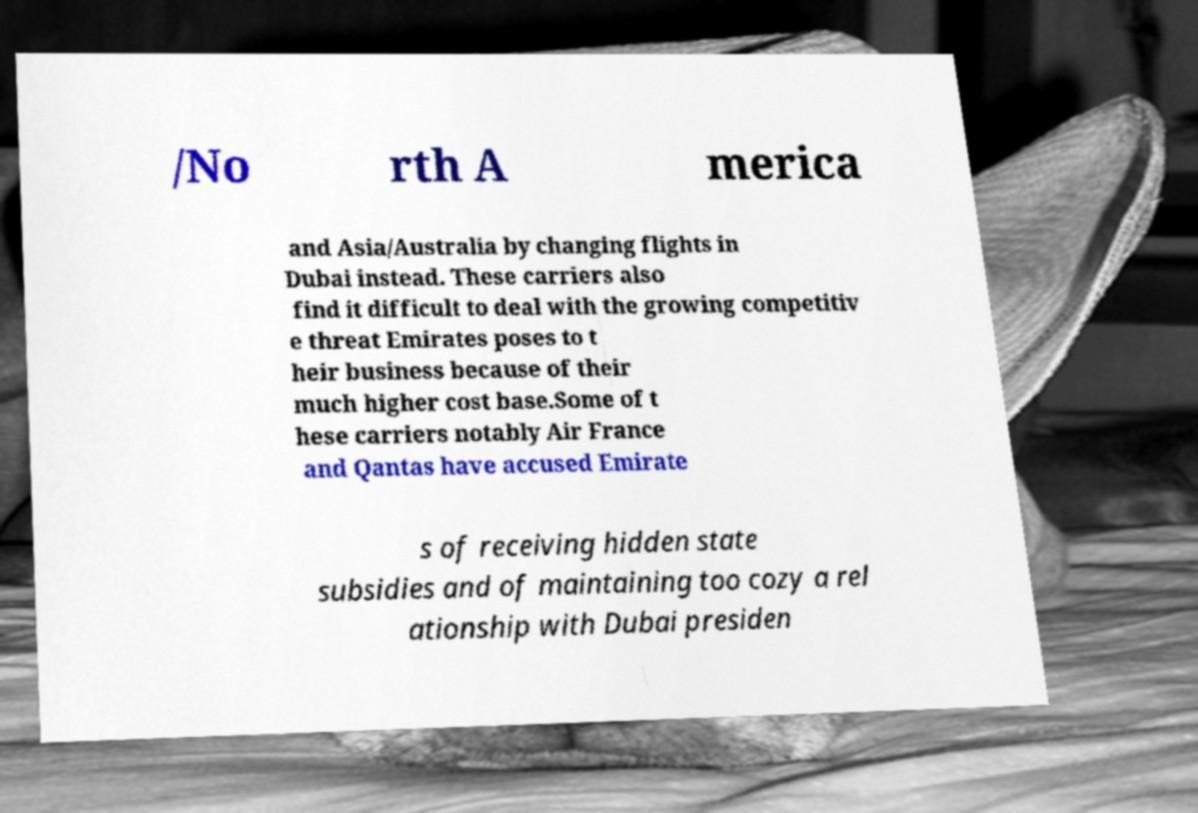Can you read and provide the text displayed in the image?This photo seems to have some interesting text. Can you extract and type it out for me? /No rth A merica and Asia/Australia by changing flights in Dubai instead. These carriers also find it difficult to deal with the growing competitiv e threat Emirates poses to t heir business because of their much higher cost base.Some of t hese carriers notably Air France and Qantas have accused Emirate s of receiving hidden state subsidies and of maintaining too cozy a rel ationship with Dubai presiden 